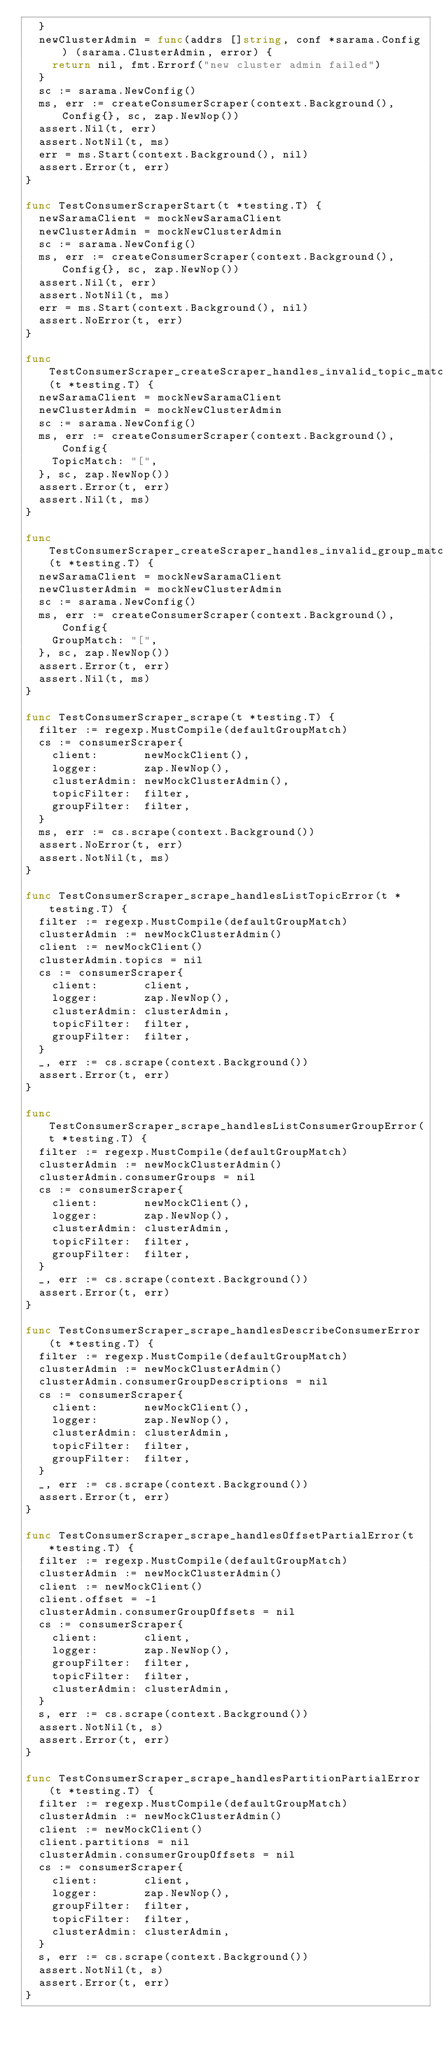<code> <loc_0><loc_0><loc_500><loc_500><_Go_>	}
	newClusterAdmin = func(addrs []string, conf *sarama.Config) (sarama.ClusterAdmin, error) {
		return nil, fmt.Errorf("new cluster admin failed")
	}
	sc := sarama.NewConfig()
	ms, err := createConsumerScraper(context.Background(), Config{}, sc, zap.NewNop())
	assert.Nil(t, err)
	assert.NotNil(t, ms)
	err = ms.Start(context.Background(), nil)
	assert.Error(t, err)
}

func TestConsumerScraperStart(t *testing.T) {
	newSaramaClient = mockNewSaramaClient
	newClusterAdmin = mockNewClusterAdmin
	sc := sarama.NewConfig()
	ms, err := createConsumerScraper(context.Background(), Config{}, sc, zap.NewNop())
	assert.Nil(t, err)
	assert.NotNil(t, ms)
	err = ms.Start(context.Background(), nil)
	assert.NoError(t, err)
}

func TestConsumerScraper_createScraper_handles_invalid_topic_match(t *testing.T) {
	newSaramaClient = mockNewSaramaClient
	newClusterAdmin = mockNewClusterAdmin
	sc := sarama.NewConfig()
	ms, err := createConsumerScraper(context.Background(), Config{
		TopicMatch: "[",
	}, sc, zap.NewNop())
	assert.Error(t, err)
	assert.Nil(t, ms)
}

func TestConsumerScraper_createScraper_handles_invalid_group_match(t *testing.T) {
	newSaramaClient = mockNewSaramaClient
	newClusterAdmin = mockNewClusterAdmin
	sc := sarama.NewConfig()
	ms, err := createConsumerScraper(context.Background(), Config{
		GroupMatch: "[",
	}, sc, zap.NewNop())
	assert.Error(t, err)
	assert.Nil(t, ms)
}

func TestConsumerScraper_scrape(t *testing.T) {
	filter := regexp.MustCompile(defaultGroupMatch)
	cs := consumerScraper{
		client:       newMockClient(),
		logger:       zap.NewNop(),
		clusterAdmin: newMockClusterAdmin(),
		topicFilter:  filter,
		groupFilter:  filter,
	}
	ms, err := cs.scrape(context.Background())
	assert.NoError(t, err)
	assert.NotNil(t, ms)
}

func TestConsumerScraper_scrape_handlesListTopicError(t *testing.T) {
	filter := regexp.MustCompile(defaultGroupMatch)
	clusterAdmin := newMockClusterAdmin()
	client := newMockClient()
	clusterAdmin.topics = nil
	cs := consumerScraper{
		client:       client,
		logger:       zap.NewNop(),
		clusterAdmin: clusterAdmin,
		topicFilter:  filter,
		groupFilter:  filter,
	}
	_, err := cs.scrape(context.Background())
	assert.Error(t, err)
}

func TestConsumerScraper_scrape_handlesListConsumerGroupError(t *testing.T) {
	filter := regexp.MustCompile(defaultGroupMatch)
	clusterAdmin := newMockClusterAdmin()
	clusterAdmin.consumerGroups = nil
	cs := consumerScraper{
		client:       newMockClient(),
		logger:       zap.NewNop(),
		clusterAdmin: clusterAdmin,
		topicFilter:  filter,
		groupFilter:  filter,
	}
	_, err := cs.scrape(context.Background())
	assert.Error(t, err)
}

func TestConsumerScraper_scrape_handlesDescribeConsumerError(t *testing.T) {
	filter := regexp.MustCompile(defaultGroupMatch)
	clusterAdmin := newMockClusterAdmin()
	clusterAdmin.consumerGroupDescriptions = nil
	cs := consumerScraper{
		client:       newMockClient(),
		logger:       zap.NewNop(),
		clusterAdmin: clusterAdmin,
		topicFilter:  filter,
		groupFilter:  filter,
	}
	_, err := cs.scrape(context.Background())
	assert.Error(t, err)
}

func TestConsumerScraper_scrape_handlesOffsetPartialError(t *testing.T) {
	filter := regexp.MustCompile(defaultGroupMatch)
	clusterAdmin := newMockClusterAdmin()
	client := newMockClient()
	client.offset = -1
	clusterAdmin.consumerGroupOffsets = nil
	cs := consumerScraper{
		client:       client,
		logger:       zap.NewNop(),
		groupFilter:  filter,
		topicFilter:  filter,
		clusterAdmin: clusterAdmin,
	}
	s, err := cs.scrape(context.Background())
	assert.NotNil(t, s)
	assert.Error(t, err)
}

func TestConsumerScraper_scrape_handlesPartitionPartialError(t *testing.T) {
	filter := regexp.MustCompile(defaultGroupMatch)
	clusterAdmin := newMockClusterAdmin()
	client := newMockClient()
	client.partitions = nil
	clusterAdmin.consumerGroupOffsets = nil
	cs := consumerScraper{
		client:       client,
		logger:       zap.NewNop(),
		groupFilter:  filter,
		topicFilter:  filter,
		clusterAdmin: clusterAdmin,
	}
	s, err := cs.scrape(context.Background())
	assert.NotNil(t, s)
	assert.Error(t, err)
}
</code> 